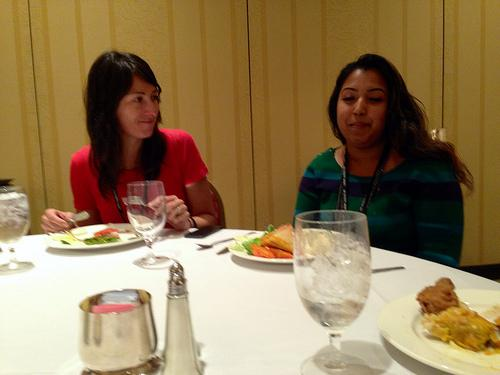Question: where are they?
Choices:
A. In the mountains.
B. In a temple.
C. At dinner.
D. In the middle of a riot.
Answer with the letter. Answer: C Question: who can be seen?
Choices:
A. Convicted felons.
B. Pirates.
C. Schoolchildren.
D. Two women.
Answer with the letter. Answer: D Question: when does this appear to be taken?
Choices:
A. During a lunar eclipse.
B. During a volcanic eruption.
C. During dinner.
D. Sunset.
Answer with the letter. Answer: C Question: what is the woman in red holding in her hands?
Choices:
A. Utensils.
B. A cat.
C. His shirt.
D. The toy car.
Answer with the letter. Answer: A Question: how do the women appear to be?
Choices:
A. Wet.
B. Dry.
C. Freezing.
D. Happy.
Answer with the letter. Answer: D 